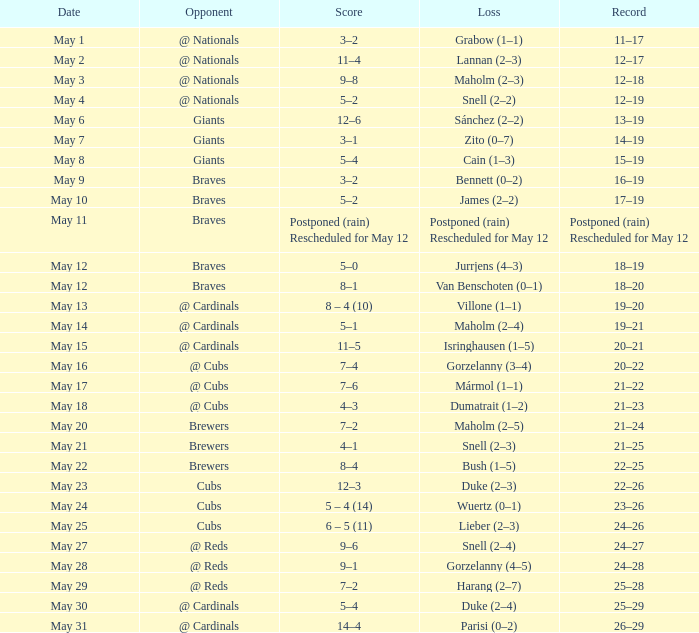What was the game's result when the score was 12-6? 13–19. 